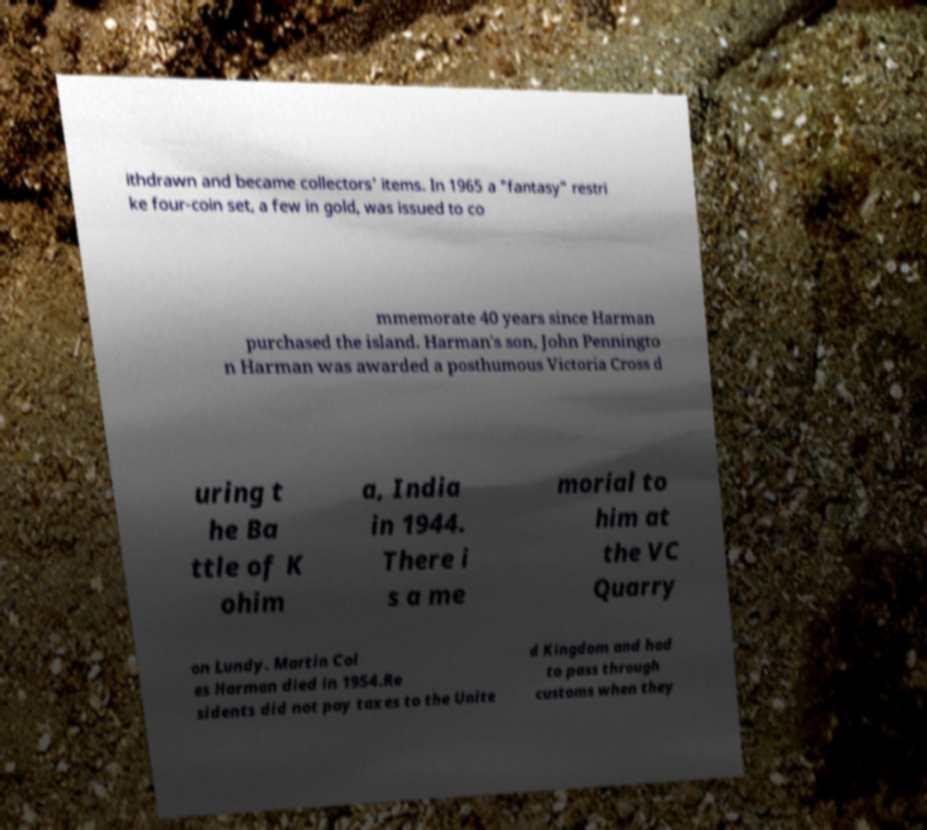What messages or text are displayed in this image? I need them in a readable, typed format. ithdrawn and became collectors' items. In 1965 a "fantasy" restri ke four-coin set, a few in gold, was issued to co mmemorate 40 years since Harman purchased the island. Harman's son, John Penningto n Harman was awarded a posthumous Victoria Cross d uring t he Ba ttle of K ohim a, India in 1944. There i s a me morial to him at the VC Quarry on Lundy. Martin Col es Harman died in 1954.Re sidents did not pay taxes to the Unite d Kingdom and had to pass through customs when they 